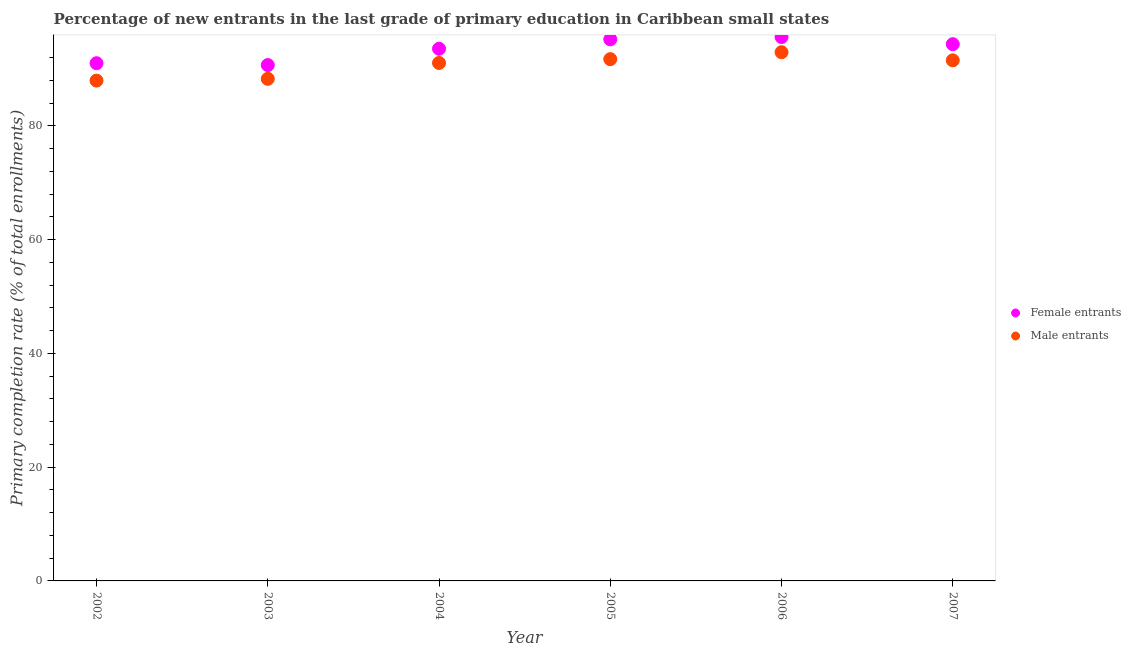How many different coloured dotlines are there?
Ensure brevity in your answer.  2. What is the primary completion rate of female entrants in 2002?
Your answer should be very brief. 90.99. Across all years, what is the maximum primary completion rate of female entrants?
Provide a short and direct response. 95.59. Across all years, what is the minimum primary completion rate of male entrants?
Make the answer very short. 87.94. In which year was the primary completion rate of male entrants minimum?
Your response must be concise. 2002. What is the total primary completion rate of female entrants in the graph?
Your response must be concise. 560.32. What is the difference between the primary completion rate of male entrants in 2002 and that in 2005?
Your answer should be very brief. -3.77. What is the difference between the primary completion rate of male entrants in 2007 and the primary completion rate of female entrants in 2004?
Ensure brevity in your answer.  -2.04. What is the average primary completion rate of female entrants per year?
Your response must be concise. 93.39. In the year 2005, what is the difference between the primary completion rate of male entrants and primary completion rate of female entrants?
Offer a terse response. -3.49. In how many years, is the primary completion rate of male entrants greater than 80 %?
Give a very brief answer. 6. What is the ratio of the primary completion rate of male entrants in 2004 to that in 2005?
Make the answer very short. 0.99. Is the primary completion rate of male entrants in 2006 less than that in 2007?
Provide a succinct answer. No. Is the difference between the primary completion rate of male entrants in 2004 and 2005 greater than the difference between the primary completion rate of female entrants in 2004 and 2005?
Give a very brief answer. Yes. What is the difference between the highest and the second highest primary completion rate of male entrants?
Provide a succinct answer. 1.22. What is the difference between the highest and the lowest primary completion rate of female entrants?
Provide a short and direct response. 4.93. In how many years, is the primary completion rate of female entrants greater than the average primary completion rate of female entrants taken over all years?
Provide a short and direct response. 4. Is the sum of the primary completion rate of male entrants in 2004 and 2005 greater than the maximum primary completion rate of female entrants across all years?
Your response must be concise. Yes. Does the primary completion rate of male entrants monotonically increase over the years?
Your answer should be compact. No. Is the primary completion rate of male entrants strictly less than the primary completion rate of female entrants over the years?
Your answer should be compact. Yes. How many dotlines are there?
Your response must be concise. 2. What is the difference between two consecutive major ticks on the Y-axis?
Ensure brevity in your answer.  20. Are the values on the major ticks of Y-axis written in scientific E-notation?
Keep it short and to the point. No. Does the graph contain any zero values?
Give a very brief answer. No. Does the graph contain grids?
Offer a terse response. No. Where does the legend appear in the graph?
Your response must be concise. Center right. What is the title of the graph?
Make the answer very short. Percentage of new entrants in the last grade of primary education in Caribbean small states. Does "Exports of goods" appear as one of the legend labels in the graph?
Offer a terse response. No. What is the label or title of the Y-axis?
Your response must be concise. Primary completion rate (% of total enrollments). What is the Primary completion rate (% of total enrollments) of Female entrants in 2002?
Make the answer very short. 90.99. What is the Primary completion rate (% of total enrollments) in Male entrants in 2002?
Your response must be concise. 87.94. What is the Primary completion rate (% of total enrollments) in Female entrants in 2003?
Ensure brevity in your answer.  90.66. What is the Primary completion rate (% of total enrollments) in Male entrants in 2003?
Ensure brevity in your answer.  88.25. What is the Primary completion rate (% of total enrollments) of Female entrants in 2004?
Your answer should be compact. 93.54. What is the Primary completion rate (% of total enrollments) of Male entrants in 2004?
Provide a short and direct response. 91.04. What is the Primary completion rate (% of total enrollments) in Female entrants in 2005?
Your answer should be compact. 95.19. What is the Primary completion rate (% of total enrollments) in Male entrants in 2005?
Your response must be concise. 91.71. What is the Primary completion rate (% of total enrollments) in Female entrants in 2006?
Ensure brevity in your answer.  95.59. What is the Primary completion rate (% of total enrollments) of Male entrants in 2006?
Your answer should be compact. 92.93. What is the Primary completion rate (% of total enrollments) of Female entrants in 2007?
Give a very brief answer. 94.34. What is the Primary completion rate (% of total enrollments) of Male entrants in 2007?
Keep it short and to the point. 91.5. Across all years, what is the maximum Primary completion rate (% of total enrollments) of Female entrants?
Offer a very short reply. 95.59. Across all years, what is the maximum Primary completion rate (% of total enrollments) in Male entrants?
Your response must be concise. 92.93. Across all years, what is the minimum Primary completion rate (% of total enrollments) in Female entrants?
Ensure brevity in your answer.  90.66. Across all years, what is the minimum Primary completion rate (% of total enrollments) in Male entrants?
Your response must be concise. 87.94. What is the total Primary completion rate (% of total enrollments) in Female entrants in the graph?
Your answer should be compact. 560.32. What is the total Primary completion rate (% of total enrollments) of Male entrants in the graph?
Offer a terse response. 543.35. What is the difference between the Primary completion rate (% of total enrollments) in Female entrants in 2002 and that in 2003?
Your answer should be very brief. 0.33. What is the difference between the Primary completion rate (% of total enrollments) in Male entrants in 2002 and that in 2003?
Offer a terse response. -0.31. What is the difference between the Primary completion rate (% of total enrollments) in Female entrants in 2002 and that in 2004?
Provide a succinct answer. -2.54. What is the difference between the Primary completion rate (% of total enrollments) of Male entrants in 2002 and that in 2004?
Your response must be concise. -3.1. What is the difference between the Primary completion rate (% of total enrollments) of Female entrants in 2002 and that in 2005?
Your answer should be compact. -4.2. What is the difference between the Primary completion rate (% of total enrollments) in Male entrants in 2002 and that in 2005?
Keep it short and to the point. -3.77. What is the difference between the Primary completion rate (% of total enrollments) in Female entrants in 2002 and that in 2006?
Give a very brief answer. -4.6. What is the difference between the Primary completion rate (% of total enrollments) of Male entrants in 2002 and that in 2006?
Ensure brevity in your answer.  -4.99. What is the difference between the Primary completion rate (% of total enrollments) of Female entrants in 2002 and that in 2007?
Provide a short and direct response. -3.34. What is the difference between the Primary completion rate (% of total enrollments) in Male entrants in 2002 and that in 2007?
Your response must be concise. -3.56. What is the difference between the Primary completion rate (% of total enrollments) of Female entrants in 2003 and that in 2004?
Your answer should be very brief. -2.87. What is the difference between the Primary completion rate (% of total enrollments) in Male entrants in 2003 and that in 2004?
Offer a very short reply. -2.79. What is the difference between the Primary completion rate (% of total enrollments) of Female entrants in 2003 and that in 2005?
Provide a succinct answer. -4.53. What is the difference between the Primary completion rate (% of total enrollments) in Male entrants in 2003 and that in 2005?
Provide a succinct answer. -3.46. What is the difference between the Primary completion rate (% of total enrollments) of Female entrants in 2003 and that in 2006?
Offer a terse response. -4.93. What is the difference between the Primary completion rate (% of total enrollments) in Male entrants in 2003 and that in 2006?
Keep it short and to the point. -4.68. What is the difference between the Primary completion rate (% of total enrollments) of Female entrants in 2003 and that in 2007?
Your response must be concise. -3.67. What is the difference between the Primary completion rate (% of total enrollments) of Male entrants in 2003 and that in 2007?
Keep it short and to the point. -3.25. What is the difference between the Primary completion rate (% of total enrollments) of Female entrants in 2004 and that in 2005?
Offer a very short reply. -1.66. What is the difference between the Primary completion rate (% of total enrollments) of Male entrants in 2004 and that in 2005?
Your answer should be very brief. -0.67. What is the difference between the Primary completion rate (% of total enrollments) in Female entrants in 2004 and that in 2006?
Your response must be concise. -2.05. What is the difference between the Primary completion rate (% of total enrollments) of Male entrants in 2004 and that in 2006?
Your answer should be compact. -1.89. What is the difference between the Primary completion rate (% of total enrollments) of Female entrants in 2004 and that in 2007?
Provide a short and direct response. -0.8. What is the difference between the Primary completion rate (% of total enrollments) of Male entrants in 2004 and that in 2007?
Give a very brief answer. -0.46. What is the difference between the Primary completion rate (% of total enrollments) in Female entrants in 2005 and that in 2006?
Make the answer very short. -0.4. What is the difference between the Primary completion rate (% of total enrollments) in Male entrants in 2005 and that in 2006?
Your response must be concise. -1.22. What is the difference between the Primary completion rate (% of total enrollments) in Female entrants in 2005 and that in 2007?
Ensure brevity in your answer.  0.86. What is the difference between the Primary completion rate (% of total enrollments) of Male entrants in 2005 and that in 2007?
Give a very brief answer. 0.21. What is the difference between the Primary completion rate (% of total enrollments) of Female entrants in 2006 and that in 2007?
Your answer should be compact. 1.25. What is the difference between the Primary completion rate (% of total enrollments) in Male entrants in 2006 and that in 2007?
Offer a terse response. 1.43. What is the difference between the Primary completion rate (% of total enrollments) of Female entrants in 2002 and the Primary completion rate (% of total enrollments) of Male entrants in 2003?
Your response must be concise. 2.75. What is the difference between the Primary completion rate (% of total enrollments) in Female entrants in 2002 and the Primary completion rate (% of total enrollments) in Male entrants in 2004?
Provide a short and direct response. -0.04. What is the difference between the Primary completion rate (% of total enrollments) of Female entrants in 2002 and the Primary completion rate (% of total enrollments) of Male entrants in 2005?
Provide a short and direct response. -0.71. What is the difference between the Primary completion rate (% of total enrollments) of Female entrants in 2002 and the Primary completion rate (% of total enrollments) of Male entrants in 2006?
Your answer should be compact. -1.93. What is the difference between the Primary completion rate (% of total enrollments) of Female entrants in 2002 and the Primary completion rate (% of total enrollments) of Male entrants in 2007?
Provide a succinct answer. -0.5. What is the difference between the Primary completion rate (% of total enrollments) of Female entrants in 2003 and the Primary completion rate (% of total enrollments) of Male entrants in 2004?
Offer a terse response. -0.37. What is the difference between the Primary completion rate (% of total enrollments) in Female entrants in 2003 and the Primary completion rate (% of total enrollments) in Male entrants in 2005?
Give a very brief answer. -1.04. What is the difference between the Primary completion rate (% of total enrollments) in Female entrants in 2003 and the Primary completion rate (% of total enrollments) in Male entrants in 2006?
Keep it short and to the point. -2.26. What is the difference between the Primary completion rate (% of total enrollments) in Female entrants in 2003 and the Primary completion rate (% of total enrollments) in Male entrants in 2007?
Your answer should be compact. -0.83. What is the difference between the Primary completion rate (% of total enrollments) in Female entrants in 2004 and the Primary completion rate (% of total enrollments) in Male entrants in 2005?
Provide a short and direct response. 1.83. What is the difference between the Primary completion rate (% of total enrollments) in Female entrants in 2004 and the Primary completion rate (% of total enrollments) in Male entrants in 2006?
Offer a terse response. 0.61. What is the difference between the Primary completion rate (% of total enrollments) of Female entrants in 2004 and the Primary completion rate (% of total enrollments) of Male entrants in 2007?
Make the answer very short. 2.04. What is the difference between the Primary completion rate (% of total enrollments) in Female entrants in 2005 and the Primary completion rate (% of total enrollments) in Male entrants in 2006?
Give a very brief answer. 2.27. What is the difference between the Primary completion rate (% of total enrollments) in Female entrants in 2005 and the Primary completion rate (% of total enrollments) in Male entrants in 2007?
Ensure brevity in your answer.  3.7. What is the difference between the Primary completion rate (% of total enrollments) in Female entrants in 2006 and the Primary completion rate (% of total enrollments) in Male entrants in 2007?
Provide a succinct answer. 4.09. What is the average Primary completion rate (% of total enrollments) in Female entrants per year?
Ensure brevity in your answer.  93.39. What is the average Primary completion rate (% of total enrollments) of Male entrants per year?
Your answer should be very brief. 90.56. In the year 2002, what is the difference between the Primary completion rate (% of total enrollments) of Female entrants and Primary completion rate (% of total enrollments) of Male entrants?
Offer a very short reply. 3.06. In the year 2003, what is the difference between the Primary completion rate (% of total enrollments) in Female entrants and Primary completion rate (% of total enrollments) in Male entrants?
Offer a terse response. 2.42. In the year 2004, what is the difference between the Primary completion rate (% of total enrollments) of Female entrants and Primary completion rate (% of total enrollments) of Male entrants?
Make the answer very short. 2.5. In the year 2005, what is the difference between the Primary completion rate (% of total enrollments) of Female entrants and Primary completion rate (% of total enrollments) of Male entrants?
Offer a terse response. 3.49. In the year 2006, what is the difference between the Primary completion rate (% of total enrollments) in Female entrants and Primary completion rate (% of total enrollments) in Male entrants?
Your answer should be very brief. 2.66. In the year 2007, what is the difference between the Primary completion rate (% of total enrollments) of Female entrants and Primary completion rate (% of total enrollments) of Male entrants?
Make the answer very short. 2.84. What is the ratio of the Primary completion rate (% of total enrollments) in Female entrants in 2002 to that in 2004?
Ensure brevity in your answer.  0.97. What is the ratio of the Primary completion rate (% of total enrollments) of Female entrants in 2002 to that in 2005?
Keep it short and to the point. 0.96. What is the ratio of the Primary completion rate (% of total enrollments) in Male entrants in 2002 to that in 2005?
Give a very brief answer. 0.96. What is the ratio of the Primary completion rate (% of total enrollments) in Female entrants in 2002 to that in 2006?
Offer a very short reply. 0.95. What is the ratio of the Primary completion rate (% of total enrollments) of Male entrants in 2002 to that in 2006?
Provide a succinct answer. 0.95. What is the ratio of the Primary completion rate (% of total enrollments) of Female entrants in 2002 to that in 2007?
Provide a short and direct response. 0.96. What is the ratio of the Primary completion rate (% of total enrollments) of Male entrants in 2002 to that in 2007?
Keep it short and to the point. 0.96. What is the ratio of the Primary completion rate (% of total enrollments) of Female entrants in 2003 to that in 2004?
Your answer should be compact. 0.97. What is the ratio of the Primary completion rate (% of total enrollments) in Male entrants in 2003 to that in 2004?
Your answer should be compact. 0.97. What is the ratio of the Primary completion rate (% of total enrollments) in Male entrants in 2003 to that in 2005?
Provide a short and direct response. 0.96. What is the ratio of the Primary completion rate (% of total enrollments) of Female entrants in 2003 to that in 2006?
Provide a short and direct response. 0.95. What is the ratio of the Primary completion rate (% of total enrollments) in Male entrants in 2003 to that in 2006?
Ensure brevity in your answer.  0.95. What is the ratio of the Primary completion rate (% of total enrollments) in Male entrants in 2003 to that in 2007?
Your answer should be compact. 0.96. What is the ratio of the Primary completion rate (% of total enrollments) in Female entrants in 2004 to that in 2005?
Offer a terse response. 0.98. What is the ratio of the Primary completion rate (% of total enrollments) in Male entrants in 2004 to that in 2005?
Ensure brevity in your answer.  0.99. What is the ratio of the Primary completion rate (% of total enrollments) of Female entrants in 2004 to that in 2006?
Make the answer very short. 0.98. What is the ratio of the Primary completion rate (% of total enrollments) of Male entrants in 2004 to that in 2006?
Keep it short and to the point. 0.98. What is the ratio of the Primary completion rate (% of total enrollments) in Female entrants in 2004 to that in 2007?
Offer a terse response. 0.99. What is the ratio of the Primary completion rate (% of total enrollments) of Female entrants in 2005 to that in 2006?
Offer a very short reply. 1. What is the ratio of the Primary completion rate (% of total enrollments) of Male entrants in 2005 to that in 2006?
Provide a short and direct response. 0.99. What is the ratio of the Primary completion rate (% of total enrollments) of Female entrants in 2005 to that in 2007?
Give a very brief answer. 1.01. What is the ratio of the Primary completion rate (% of total enrollments) of Male entrants in 2005 to that in 2007?
Make the answer very short. 1. What is the ratio of the Primary completion rate (% of total enrollments) in Female entrants in 2006 to that in 2007?
Keep it short and to the point. 1.01. What is the ratio of the Primary completion rate (% of total enrollments) in Male entrants in 2006 to that in 2007?
Provide a succinct answer. 1.02. What is the difference between the highest and the second highest Primary completion rate (% of total enrollments) of Female entrants?
Ensure brevity in your answer.  0.4. What is the difference between the highest and the second highest Primary completion rate (% of total enrollments) of Male entrants?
Offer a terse response. 1.22. What is the difference between the highest and the lowest Primary completion rate (% of total enrollments) in Female entrants?
Your response must be concise. 4.93. What is the difference between the highest and the lowest Primary completion rate (% of total enrollments) of Male entrants?
Provide a succinct answer. 4.99. 